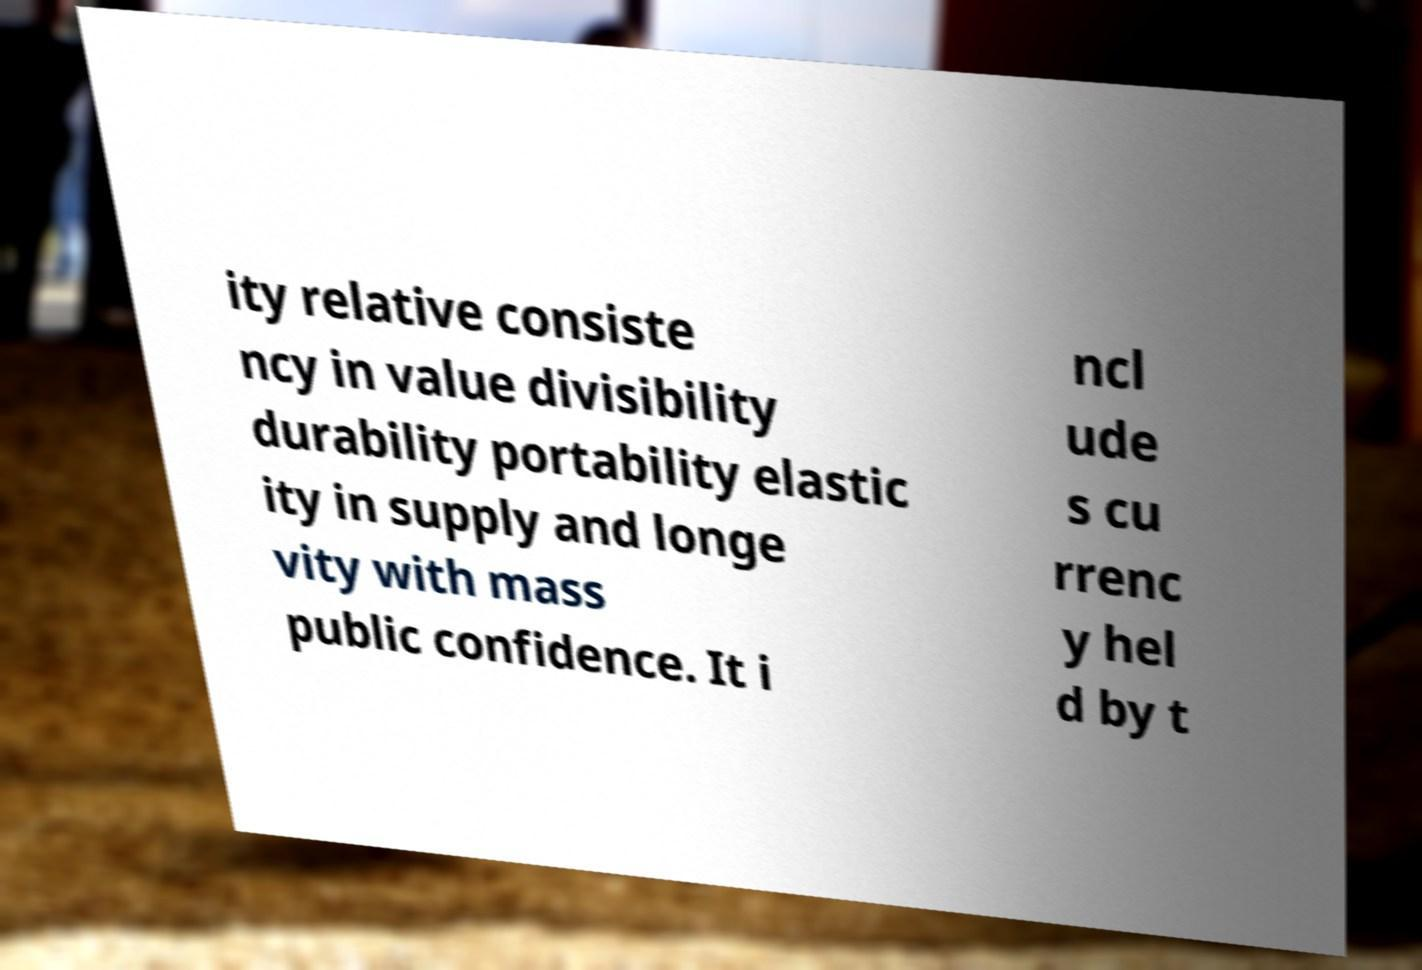Could you extract and type out the text from this image? ity relative consiste ncy in value divisibility durability portability elastic ity in supply and longe vity with mass public confidence. It i ncl ude s cu rrenc y hel d by t 